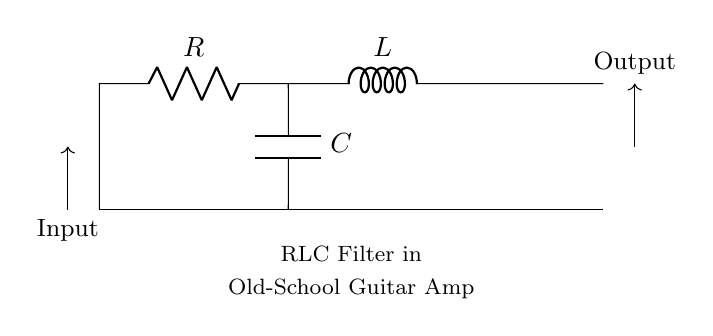What type of components are used in this circuit? The circuit contains a resistor, an inductor, and a capacitor, which are the fundamental components of an RLC filter.
Answer: Resistor, Inductor, Capacitor Where is the capacitor located in the circuit? The capacitor is connected between the resistor and the ground, indicating it is in parallel with the output.
Answer: Between the resistor and ground What is the purpose of this RLC circuit in a guitar amplifier? The circuit functions as a filter to control the tone, allowing specific frequencies to pass while attenuating others, which is essential for shaping sound.
Answer: Tone control What is the input connection direction in this circuit? The input is denoted by an arrow pointing into the circuit from the left, showing that the signal enters the circuit from that direction.
Answer: Left to right How many components does this circuit have in total? By counting, we see there are three main components: one resistor, one inductor, and one capacitor, totaling three components in the circuit.
Answer: Three What is the expected effect of increasing the capacitance in this circuit? Increasing the capacitance generally lowers the cutoff frequency of the filter, meaning it allows more lower frequencies to pass through and affects the tone produced by the amplifier.
Answer: Lowers cutoff frequency What happens to the output if the inductor value is increased? Increasing the inductor value typically increases the impedance at higher frequencies, which can attenuate these frequencies more and affect the overall sound quality from the amplifier.
Answer: Attenuates high frequencies 